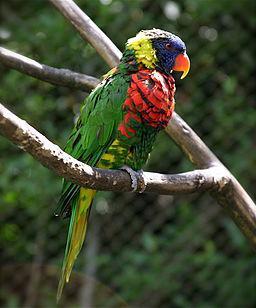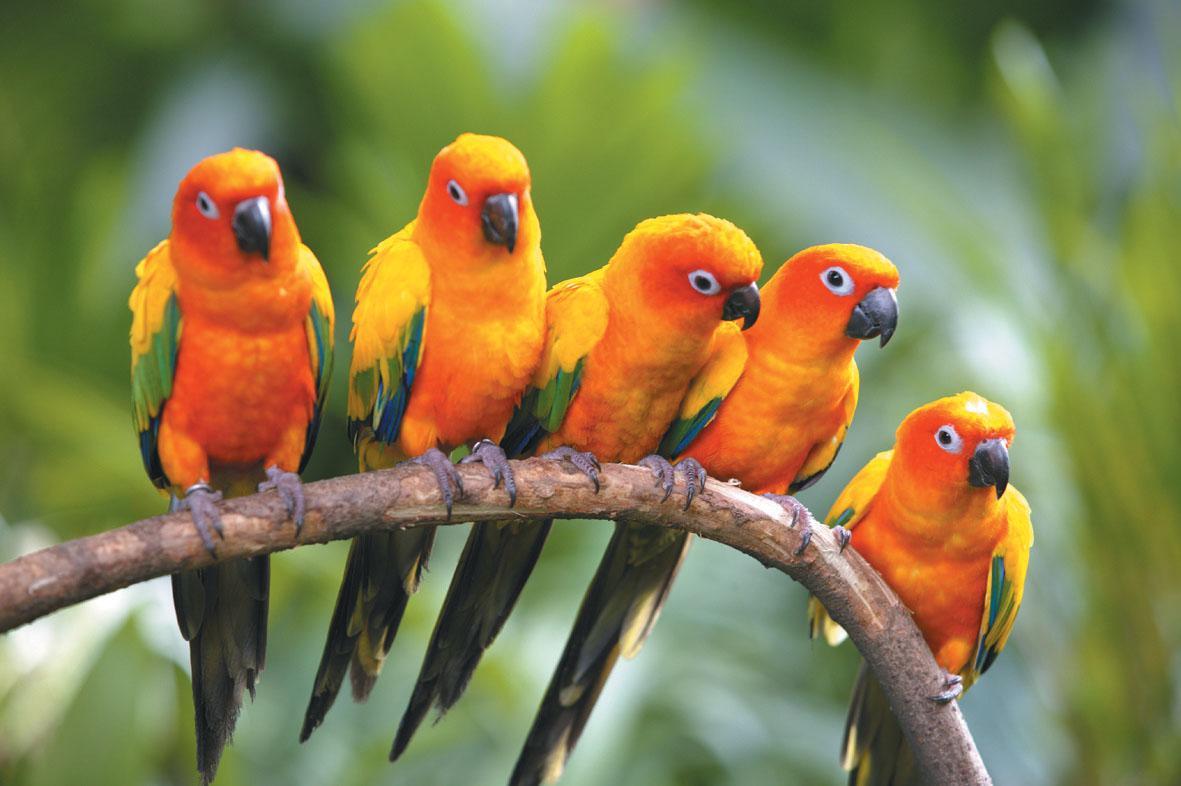The first image is the image on the left, the second image is the image on the right. Considering the images on both sides, is "There is exactly one bird in the iamge on the right" valid? Answer yes or no. No. 